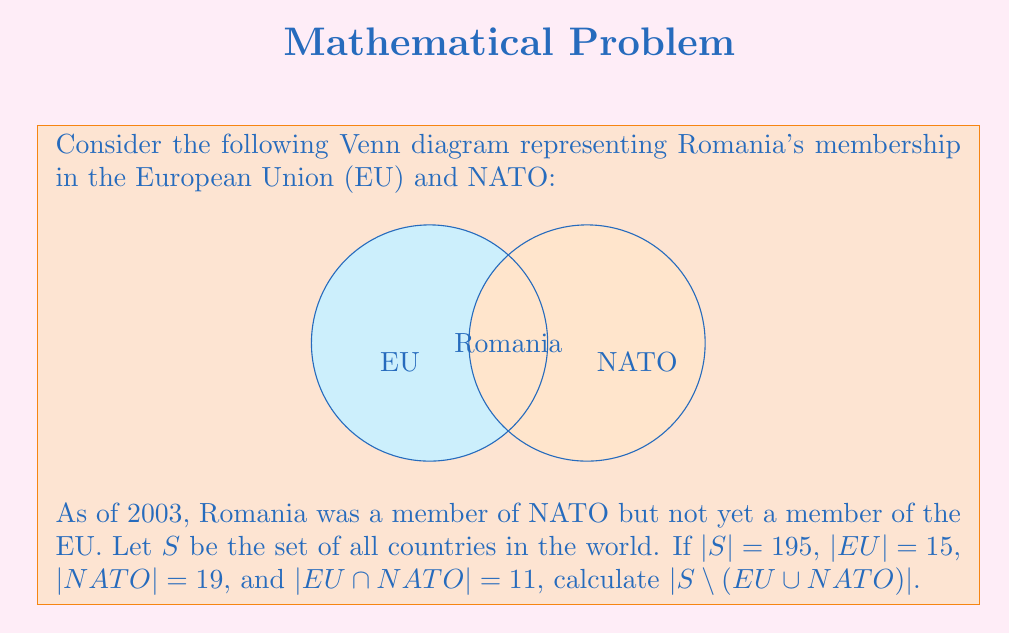Teach me how to tackle this problem. Let's approach this step-by-step:

1) First, we need to understand what $|S \setminus (EU \cup NATO)|$ means. This represents the number of countries that are neither in the EU nor in NATO.

2) To find this, we can use the formula:
   $|S \setminus (EU \cup NATO)| = |S| - |EU \cup NATO|$

3) We know $|S| = 195$, so we need to calculate $|EU \cup NATO|$.

4) We can use the inclusion-exclusion principle:
   $|EU \cup NATO| = |EU| + |NATO| - |EU \cap NATO|$

5) We're given:
   $|EU| = 15$
   $|NATO| = 19$
   $|EU \cap NATO| = 11$

6) Let's substitute these values:
   $|EU \cup NATO| = 15 + 19 - 11 = 23$

7) Now we can calculate $|S \setminus (EU \cup NATO)|$:
   $|S \setminus (EU \cup NATO)| = |S| - |EU \cup NATO|$
   $= 195 - 23 = 172$

Therefore, there are 172 countries that are neither in the EU nor in NATO as of 2003.
Answer: 172 